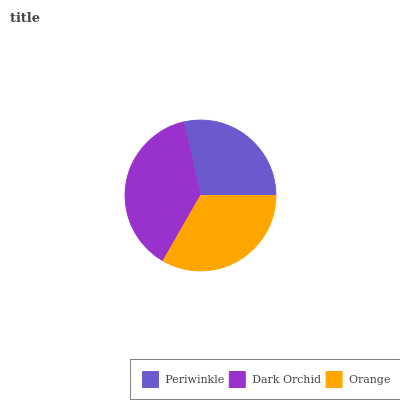Is Periwinkle the minimum?
Answer yes or no. Yes. Is Dark Orchid the maximum?
Answer yes or no. Yes. Is Orange the minimum?
Answer yes or no. No. Is Orange the maximum?
Answer yes or no. No. Is Dark Orchid greater than Orange?
Answer yes or no. Yes. Is Orange less than Dark Orchid?
Answer yes or no. Yes. Is Orange greater than Dark Orchid?
Answer yes or no. No. Is Dark Orchid less than Orange?
Answer yes or no. No. Is Orange the high median?
Answer yes or no. Yes. Is Orange the low median?
Answer yes or no. Yes. Is Dark Orchid the high median?
Answer yes or no. No. Is Periwinkle the low median?
Answer yes or no. No. 